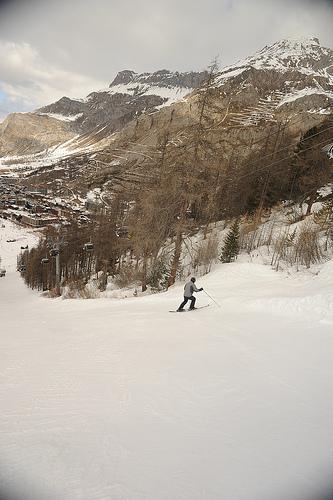How many people can be seen?
Give a very brief answer. 1. How many ski lift chairs are visible?
Give a very brief answer. 4. 